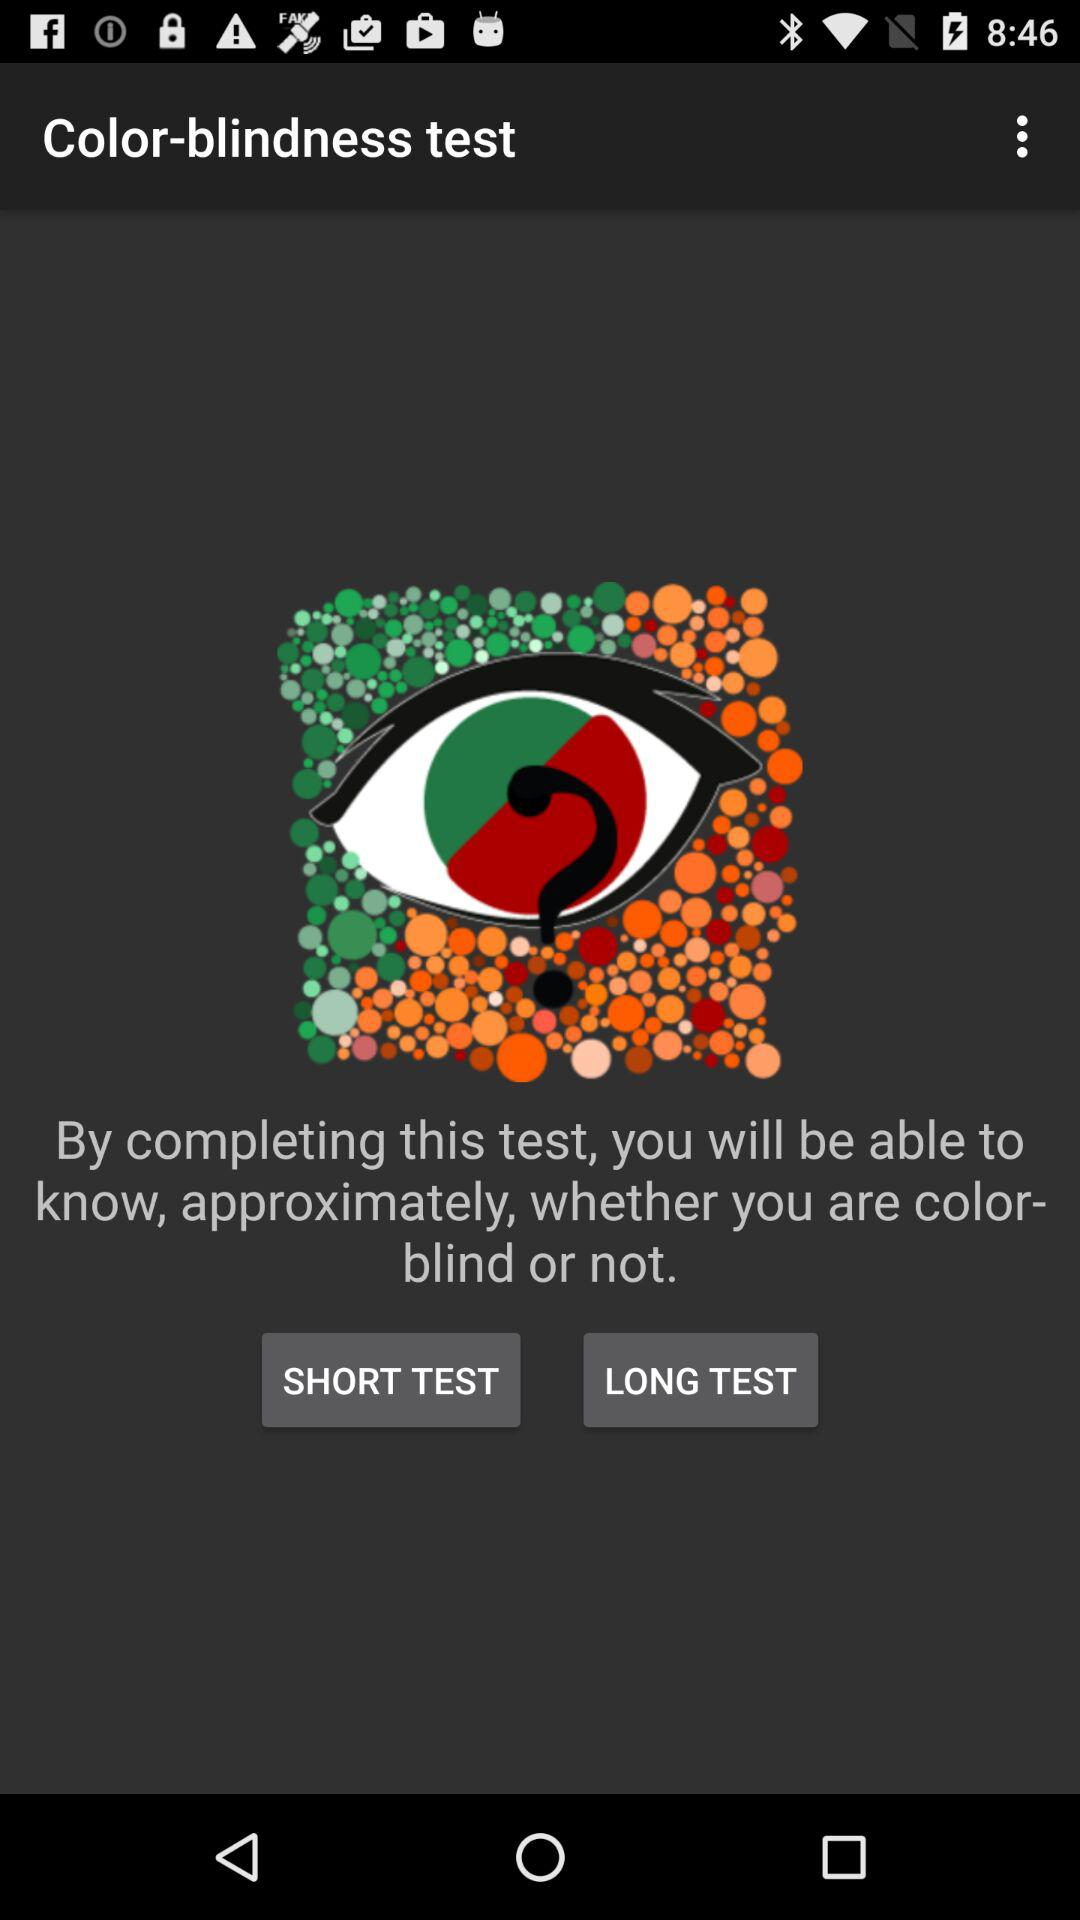What is the name of the application? The name of the application is "Color-blindness test". 